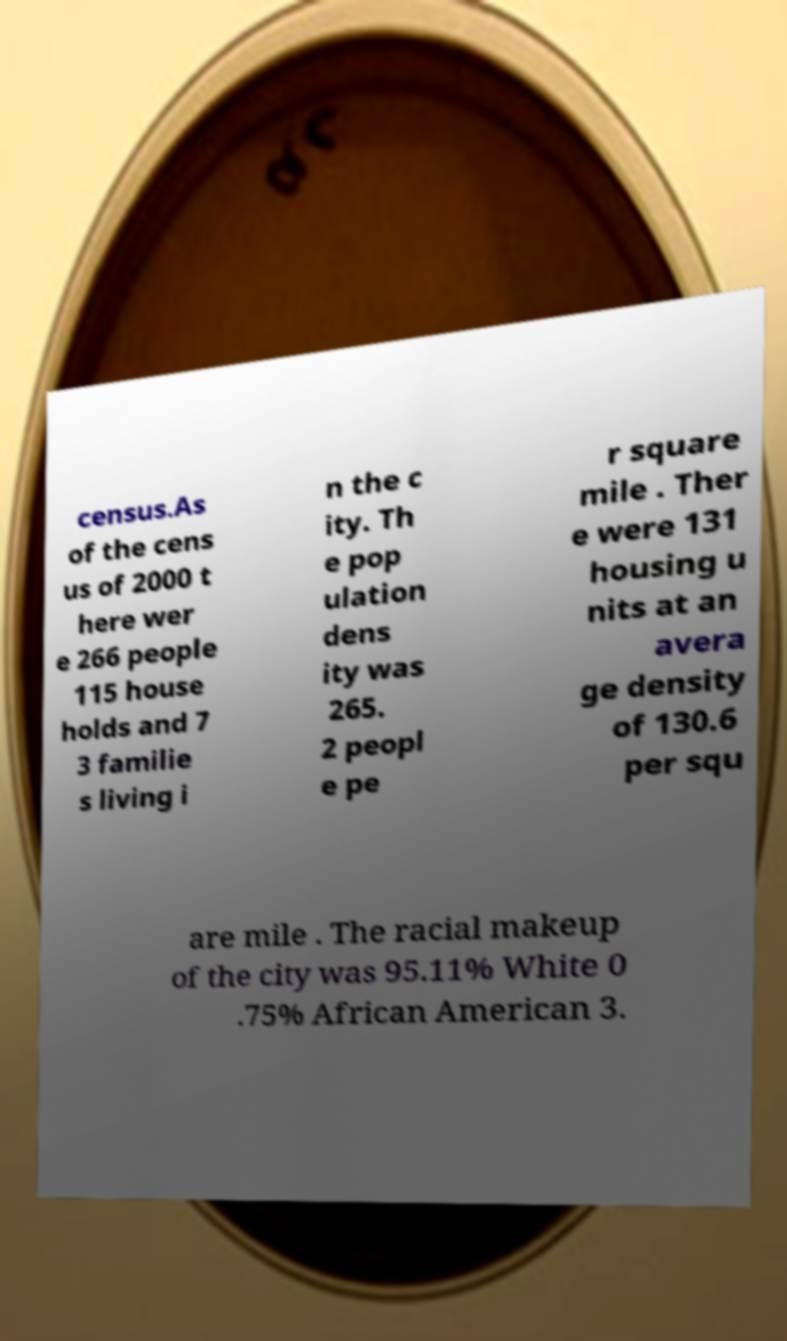Could you assist in decoding the text presented in this image and type it out clearly? census.As of the cens us of 2000 t here wer e 266 people 115 house holds and 7 3 familie s living i n the c ity. Th e pop ulation dens ity was 265. 2 peopl e pe r square mile . Ther e were 131 housing u nits at an avera ge density of 130.6 per squ are mile . The racial makeup of the city was 95.11% White 0 .75% African American 3. 